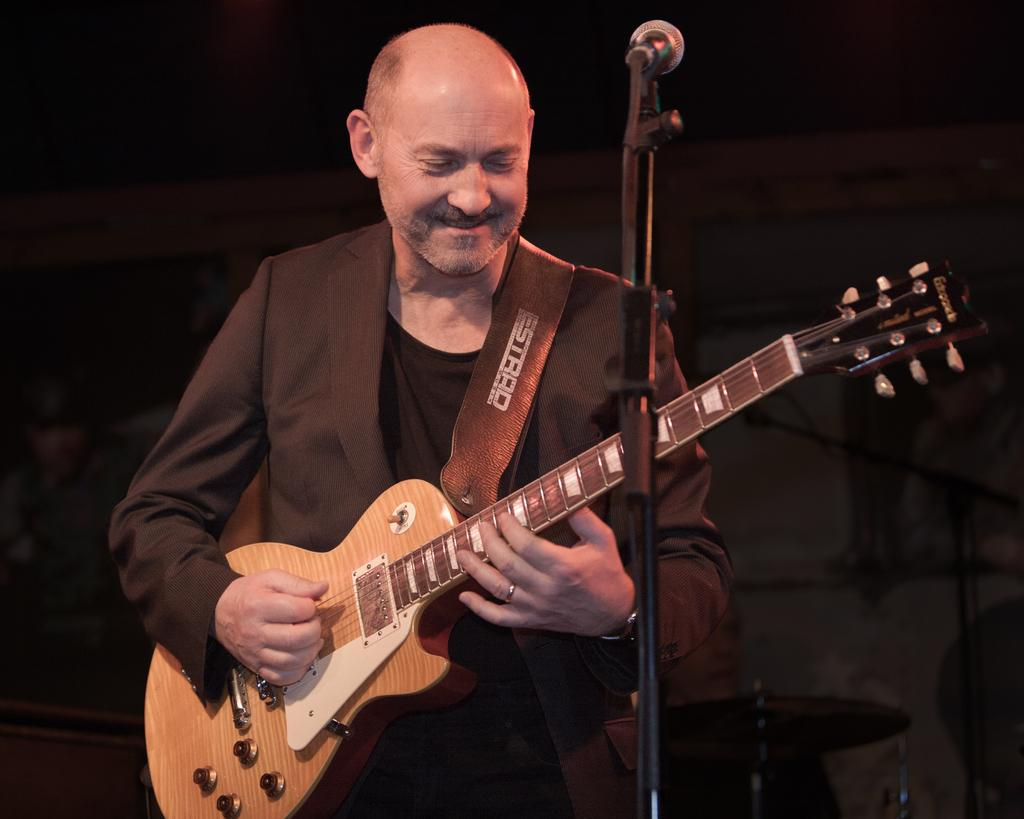Who is the main subject in the image? There is a man in the image. What is the man doing in the image? The man is playing a guitar and smiling. What equipment is set up in front of the man? There is a microphone and a microphone stand in front of the man. What is the color of the background in the image? The background of the image is black. Can you see any bananas being peeled in the image? There are no bananas or any peeling action present in the image. What type of powder is being used by the man in the image? There is no powder or any indication of its use in the image. 